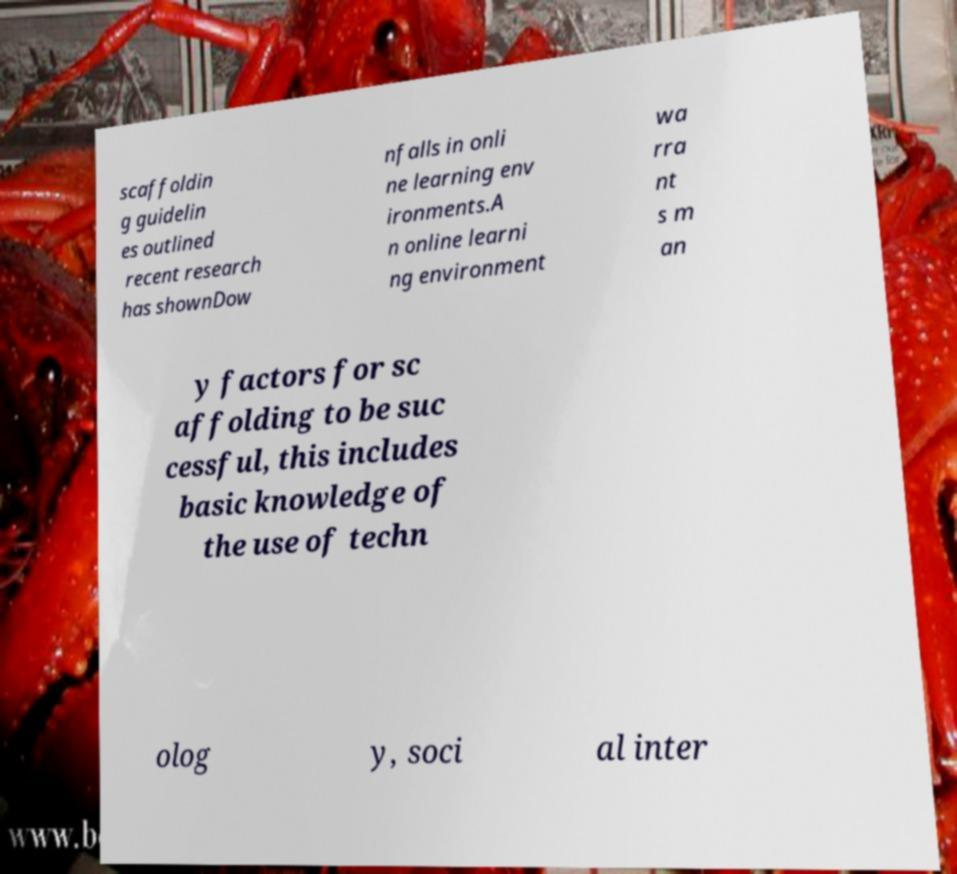Can you accurately transcribe the text from the provided image for me? scaffoldin g guidelin es outlined recent research has shownDow nfalls in onli ne learning env ironments.A n online learni ng environment wa rra nt s m an y factors for sc affolding to be suc cessful, this includes basic knowledge of the use of techn olog y, soci al inter 